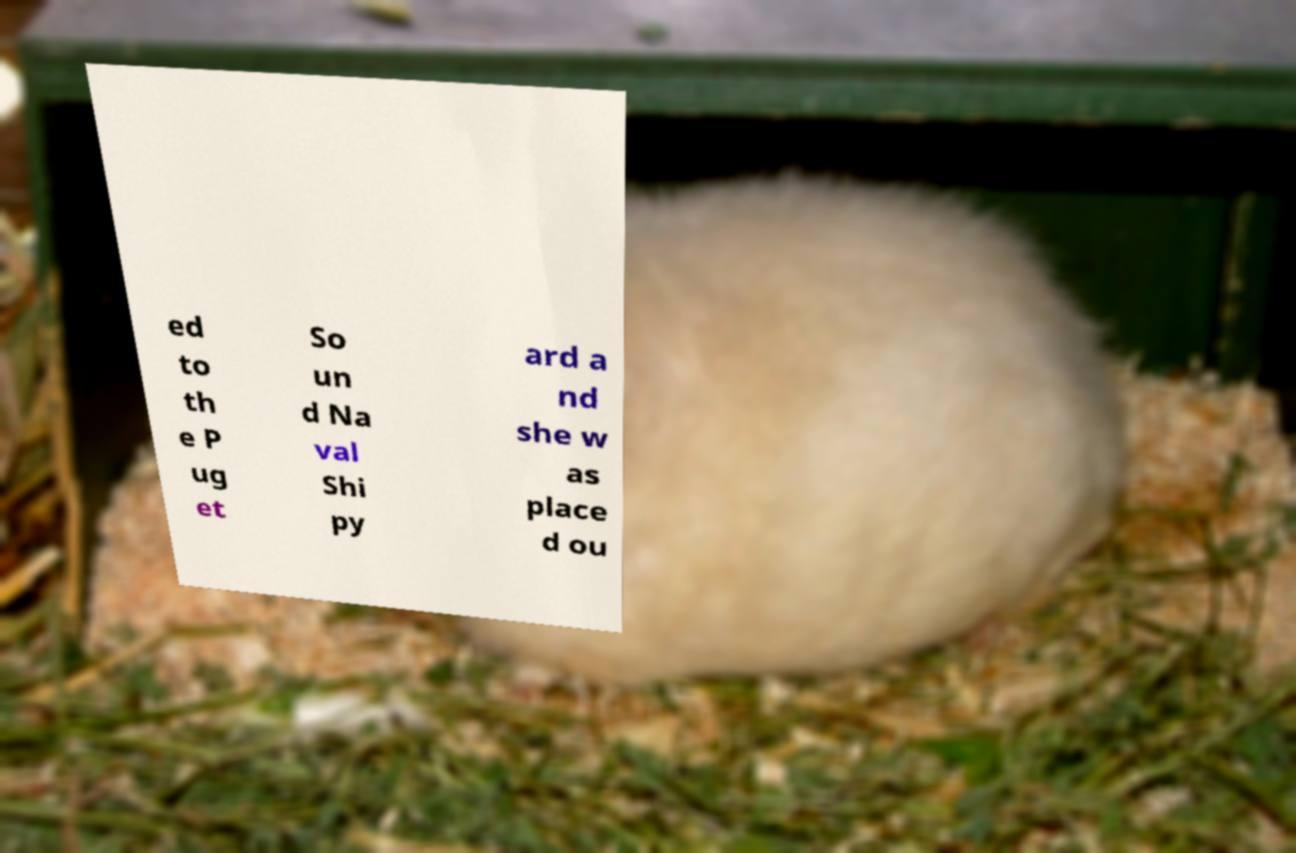Could you assist in decoding the text presented in this image and type it out clearly? ed to th e P ug et So un d Na val Shi py ard a nd she w as place d ou 